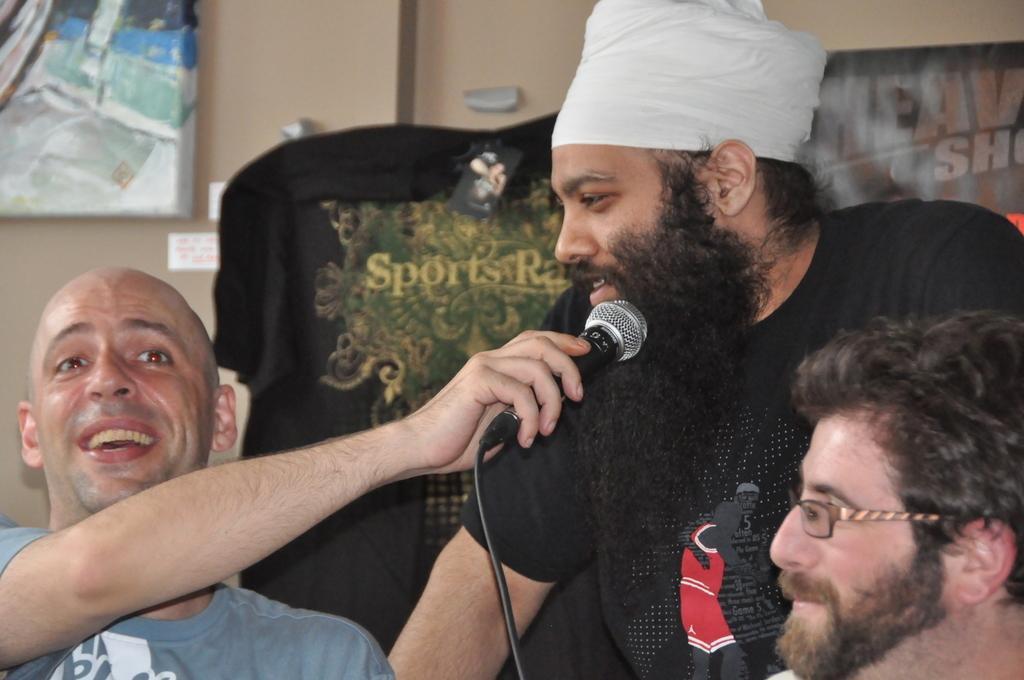Please provide a concise description of this image. In the image we can see three men wearing clothes and they are smiling. The left side man is holding a microphone in his hand and this is a cable wire. There is a wall and poster is stick to the wall. 